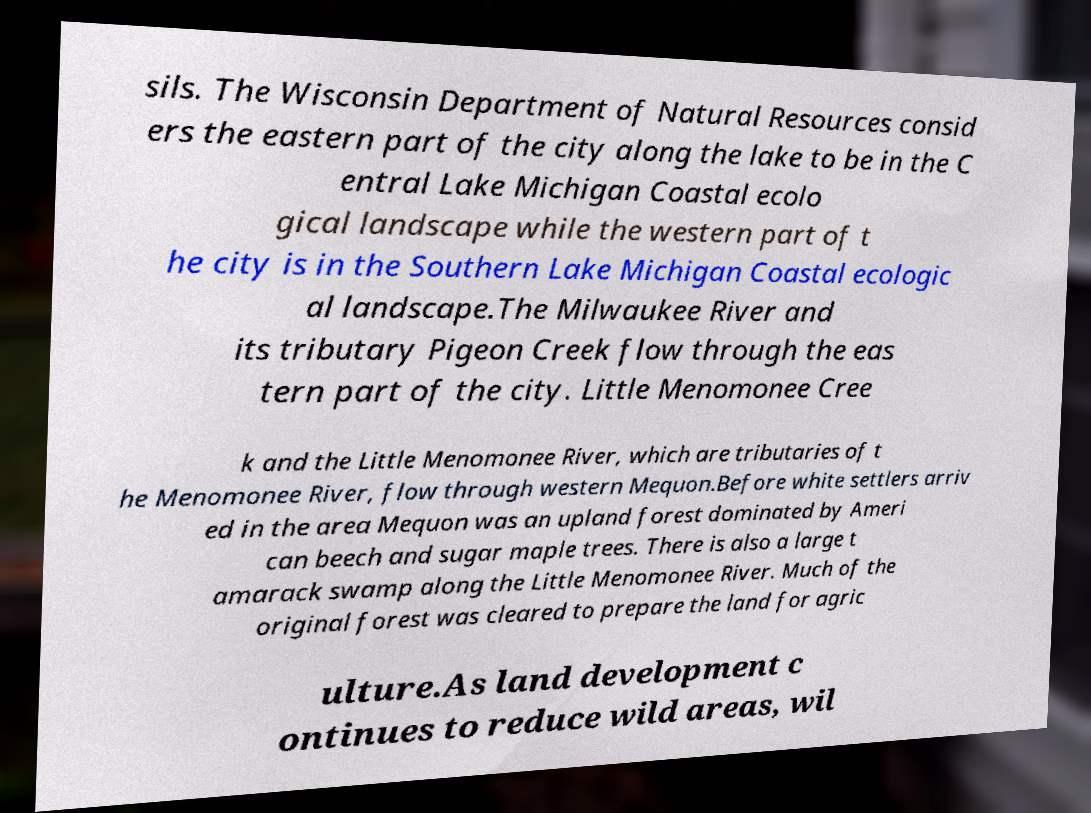There's text embedded in this image that I need extracted. Can you transcribe it verbatim? sils. The Wisconsin Department of Natural Resources consid ers the eastern part of the city along the lake to be in the C entral Lake Michigan Coastal ecolo gical landscape while the western part of t he city is in the Southern Lake Michigan Coastal ecologic al landscape.The Milwaukee River and its tributary Pigeon Creek flow through the eas tern part of the city. Little Menomonee Cree k and the Little Menomonee River, which are tributaries of t he Menomonee River, flow through western Mequon.Before white settlers arriv ed in the area Mequon was an upland forest dominated by Ameri can beech and sugar maple trees. There is also a large t amarack swamp along the Little Menomonee River. Much of the original forest was cleared to prepare the land for agric ulture.As land development c ontinues to reduce wild areas, wil 